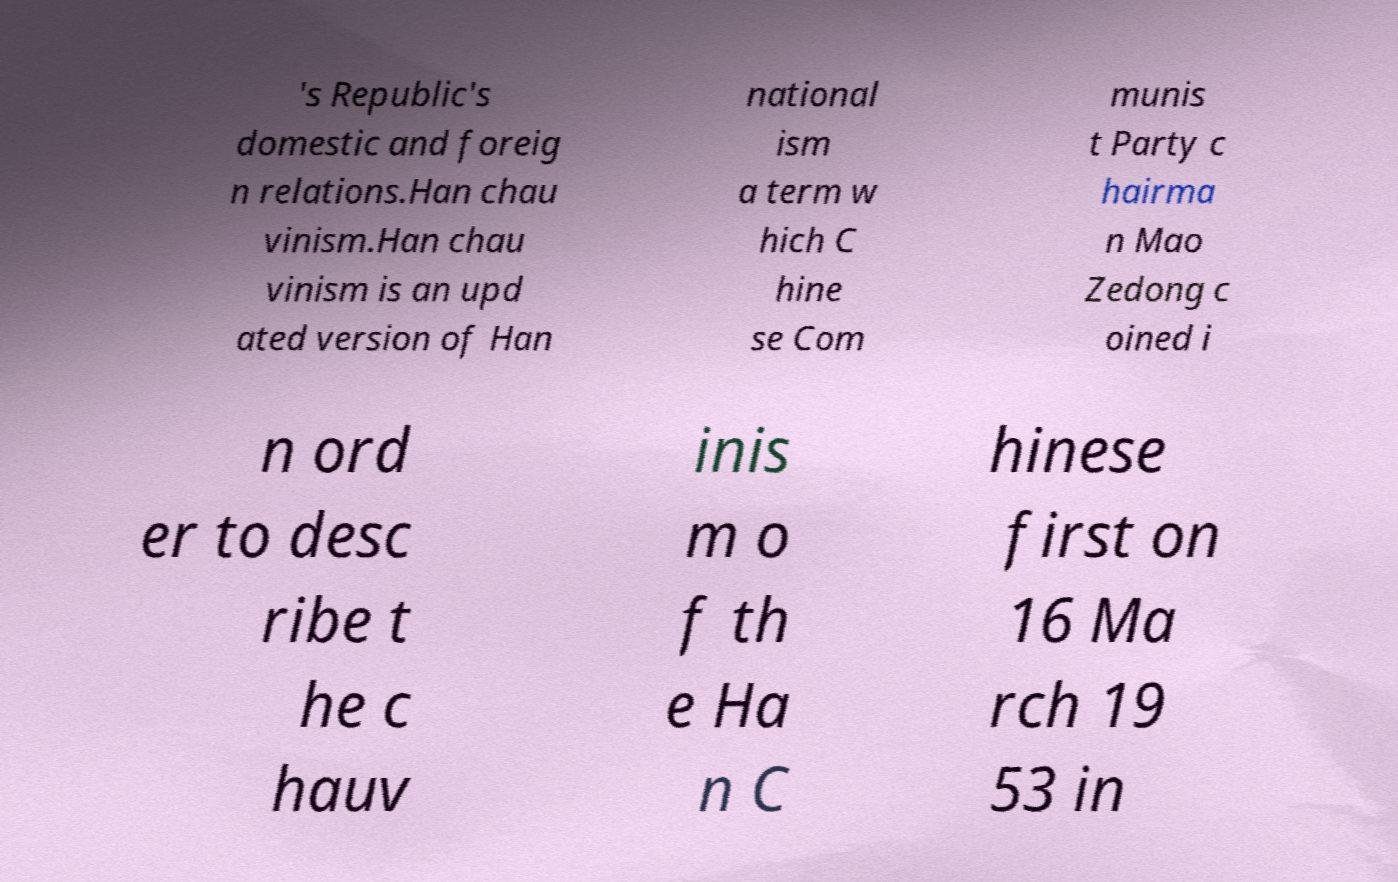Could you assist in decoding the text presented in this image and type it out clearly? 's Republic's domestic and foreig n relations.Han chau vinism.Han chau vinism is an upd ated version of Han national ism a term w hich C hine se Com munis t Party c hairma n Mao Zedong c oined i n ord er to desc ribe t he c hauv inis m o f th e Ha n C hinese first on 16 Ma rch 19 53 in 